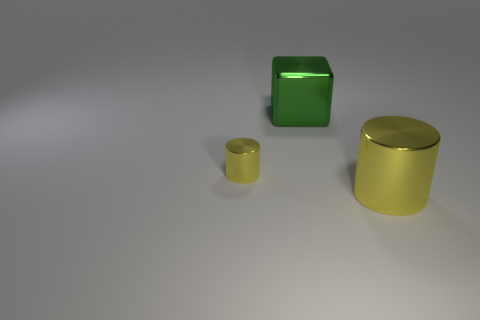How many other metallic objects have the same shape as the tiny metal thing?
Make the answer very short. 1. Do the big metallic cylinder and the small cylinder have the same color?
Ensure brevity in your answer.  Yes. Are there fewer metallic things than yellow cylinders?
Ensure brevity in your answer.  No. What is the material of the yellow object that is on the left side of the large yellow metallic cylinder?
Keep it short and to the point. Metal. What is the material of the other thing that is the same size as the green metallic object?
Your response must be concise. Metal. The thing behind the yellow thing behind the large object on the right side of the green metallic block is made of what material?
Provide a short and direct response. Metal. Is the size of the cylinder that is on the left side of the green metallic cube the same as the metallic cube?
Give a very brief answer. No. Is the number of shiny cylinders greater than the number of tiny things?
Your answer should be very brief. Yes. What number of big things are green cubes or yellow cylinders?
Your answer should be very brief. 2. What number of other objects are there of the same color as the big metal block?
Offer a very short reply. 0. 